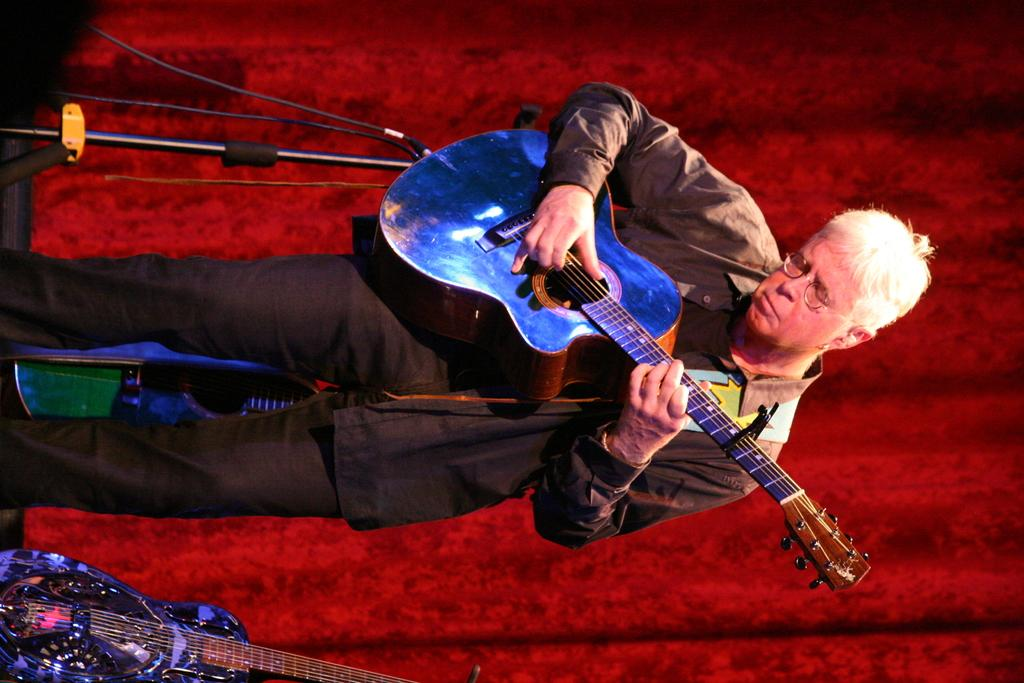Who is the main subject in the image? There is a man in the image. Where is the man located? The man is standing on a stage. What is the man holding in the image? The man is holding a guitar. What can be seen in the background of the image? There is a red curtain in the background of the image. What type of alarm is the man trying to untie with a tramp in the image? There is no alarm or tramp present in the image. The man is holding a guitar and standing on a stage with a red curtain in the background. 